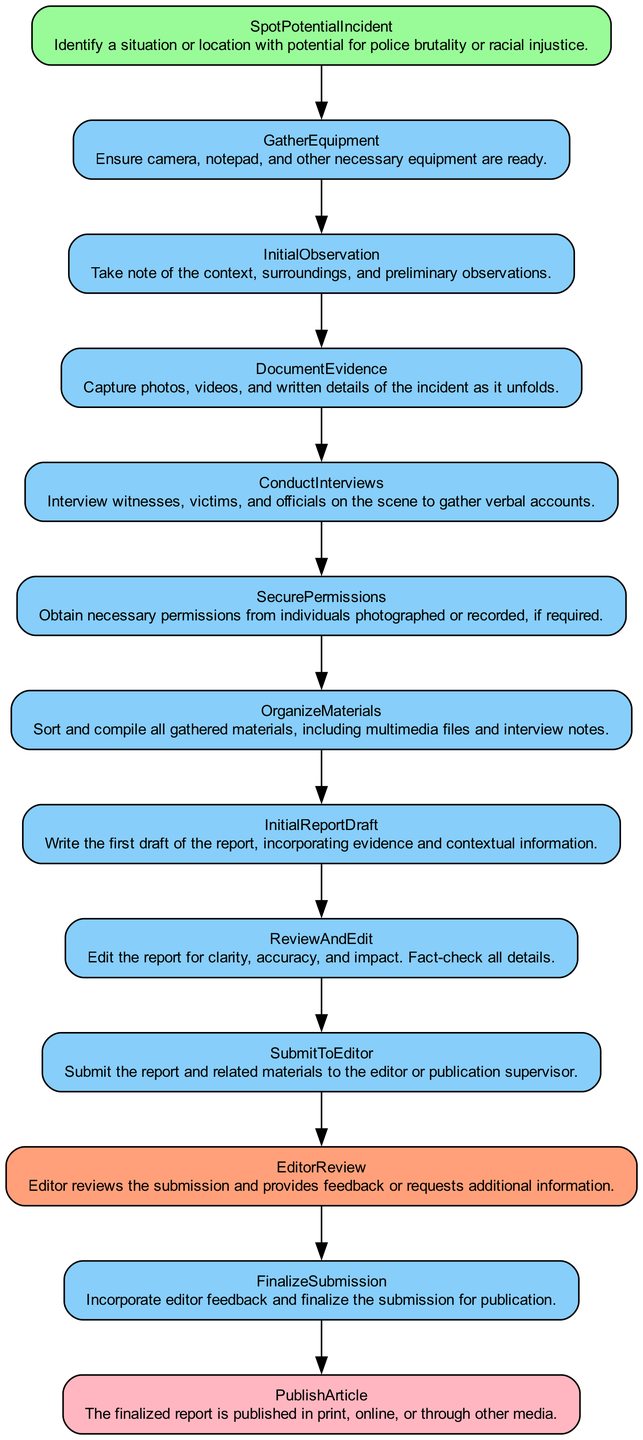What is the first step in the process? The first step according to the diagram is "SpotPotentialIncident," where a situation with potential for police brutality or racial injustice is identified.
Answer: SpotPotentialIncident How many action nodes are there? By counting the action nodes identified in the diagram, there are 8 action nodes in total.
Answer: 8 What follows after "DocumentEvidence"? The next step following "DocumentEvidence" is "ConductInterviews," where verbal accounts are gathered from witnesses, victims, and officials.
Answer: ConductInterviews What type of node is "EditorReview"? The "EditorReview" is a decision node in this flow chart. It indicates a point where the editor assesses the submission and may provide feedback.
Answer: decision What is the final step in the process? The final step described in the diagram is "PublishArticle," marking the completion of the documentation process as the report is published.
Answer: PublishArticle What action must be taken before "FinalizeSubmission"? Before moving to "FinalizeSubmission," the previously collected feedback must be incorporated into the report after the "EditorReview."
Answer: Incorporate editor feedback What is needed before "DocumentEvidence"? The action "GatherEquipment" is necessary before "DocumentEvidence" to ensure that the photographer has all required tools ready for documentation.
Answer: GatherEquipment How do you move from "InitialReportDraft" to "SubmitToEditor"? The transition from "InitialReportDraft" to "SubmitToEditor" happens sequentially; after completing the draft, it is submitted to the editor for further review.
Answer: SubmitToEditor 